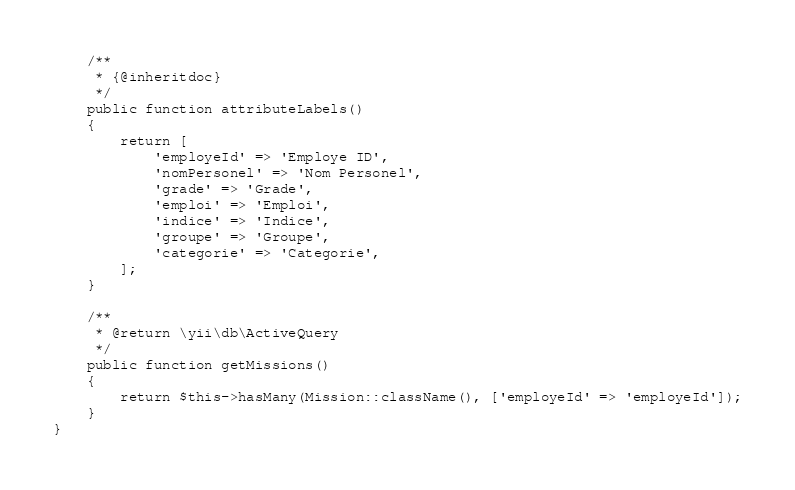Convert code to text. <code><loc_0><loc_0><loc_500><loc_500><_PHP_>    /**
     * {@inheritdoc}
     */
    public function attributeLabels()
    {
        return [
            'employeId' => 'Employe ID',
            'nomPersonel' => 'Nom Personel',
            'grade' => 'Grade',
            'emploi' => 'Emploi',
            'indice' => 'Indice',
            'groupe' => 'Groupe',
            'categorie' => 'Categorie',
        ];
    }

    /**
     * @return \yii\db\ActiveQuery
     */
    public function getMissions()
    {
        return $this->hasMany(Mission::className(), ['employeId' => 'employeId']);
    }
}
</code> 